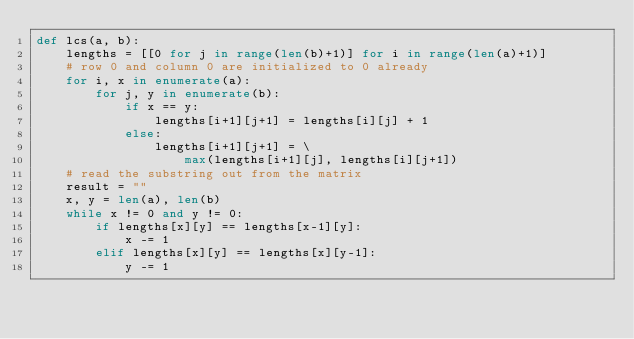Convert code to text. <code><loc_0><loc_0><loc_500><loc_500><_Python_>def lcs(a, b):
    lengths = [[0 for j in range(len(b)+1)] for i in range(len(a)+1)]
    # row 0 and column 0 are initialized to 0 already
    for i, x in enumerate(a):
        for j, y in enumerate(b):
            if x == y:
                lengths[i+1][j+1] = lengths[i][j] + 1
            else:
                lengths[i+1][j+1] = \
                    max(lengths[i+1][j], lengths[i][j+1])
    # read the substring out from the matrix
    result = ""
    x, y = len(a), len(b)
    while x != 0 and y != 0:
        if lengths[x][y] == lengths[x-1][y]:
            x -= 1
        elif lengths[x][y] == lengths[x][y-1]:
            y -= 1</code> 